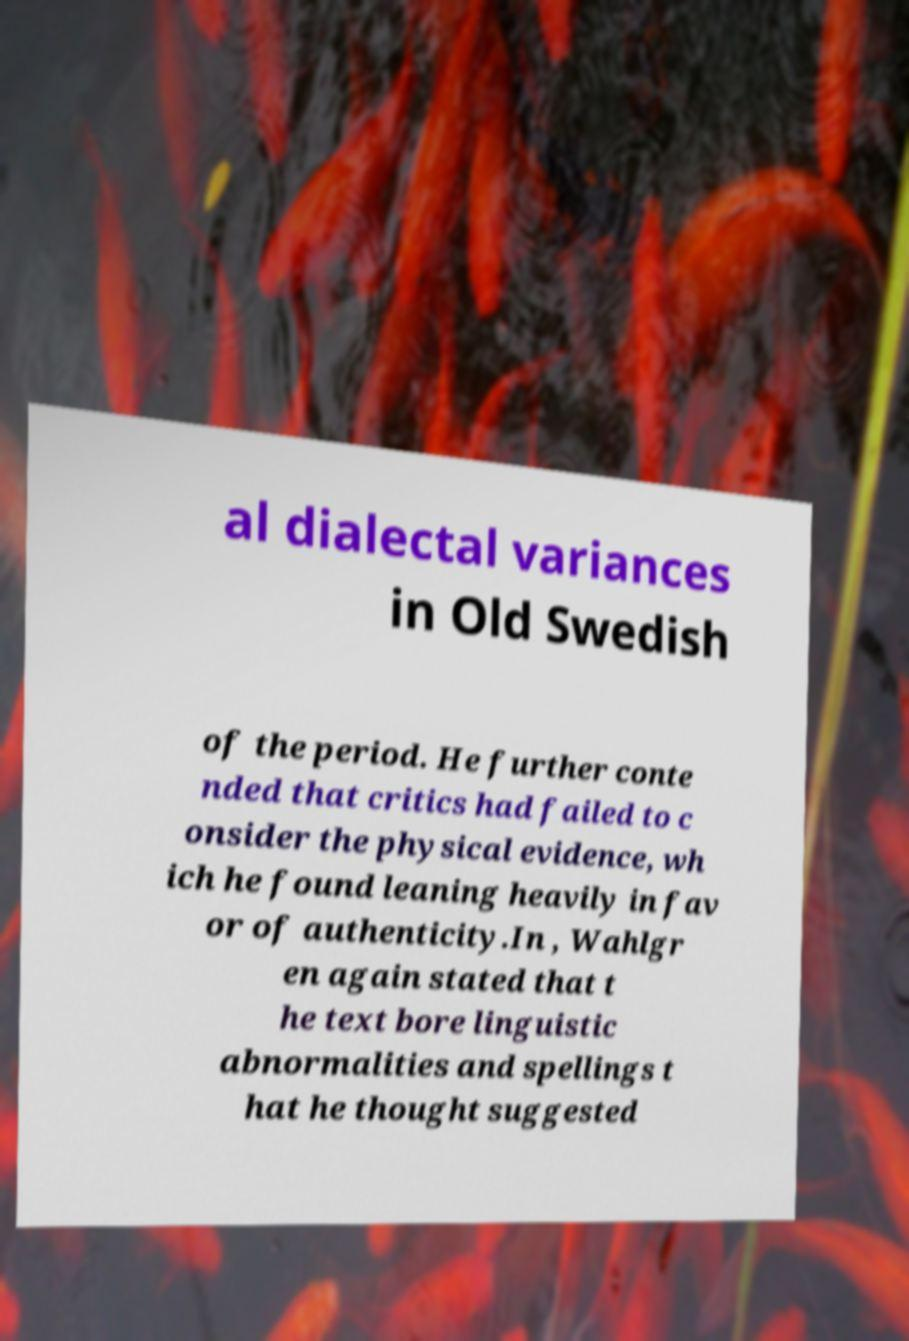Could you assist in decoding the text presented in this image and type it out clearly? al dialectal variances in Old Swedish of the period. He further conte nded that critics had failed to c onsider the physical evidence, wh ich he found leaning heavily in fav or of authenticity.In , Wahlgr en again stated that t he text bore linguistic abnormalities and spellings t hat he thought suggested 